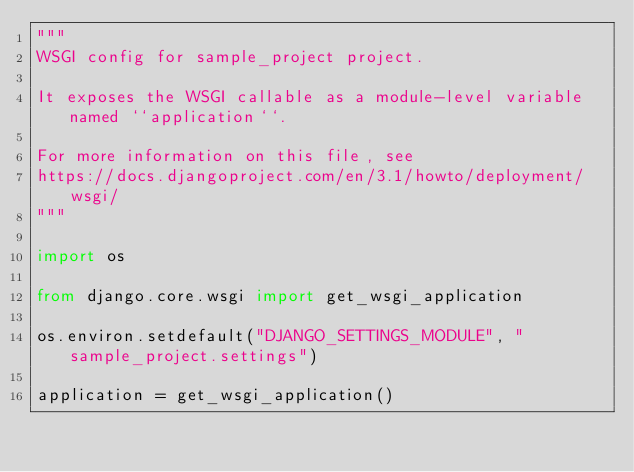Convert code to text. <code><loc_0><loc_0><loc_500><loc_500><_Python_>"""
WSGI config for sample_project project.

It exposes the WSGI callable as a module-level variable named ``application``.

For more information on this file, see
https://docs.djangoproject.com/en/3.1/howto/deployment/wsgi/
"""

import os

from django.core.wsgi import get_wsgi_application

os.environ.setdefault("DJANGO_SETTINGS_MODULE", "sample_project.settings")

application = get_wsgi_application()
</code> 